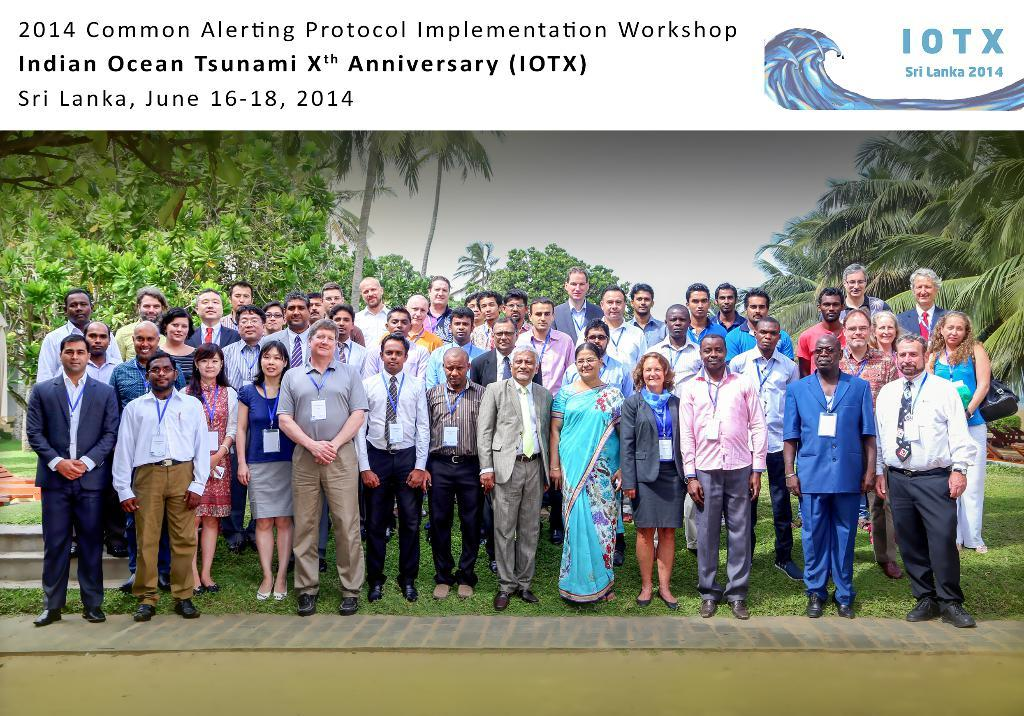What is the nature of the image? The image is edited. What is the ground surface that the people are standing on? The people are standing on the grass. What can be seen in the background of the image? There are trees and the sky visible in the background of the image. Is there any text present in the image? Yes, there is text written at the top of the image. What type of chin can be seen on the tree in the image? There is no chin present in the image, as it features people standing on grass, trees in the background, and text at the top. 